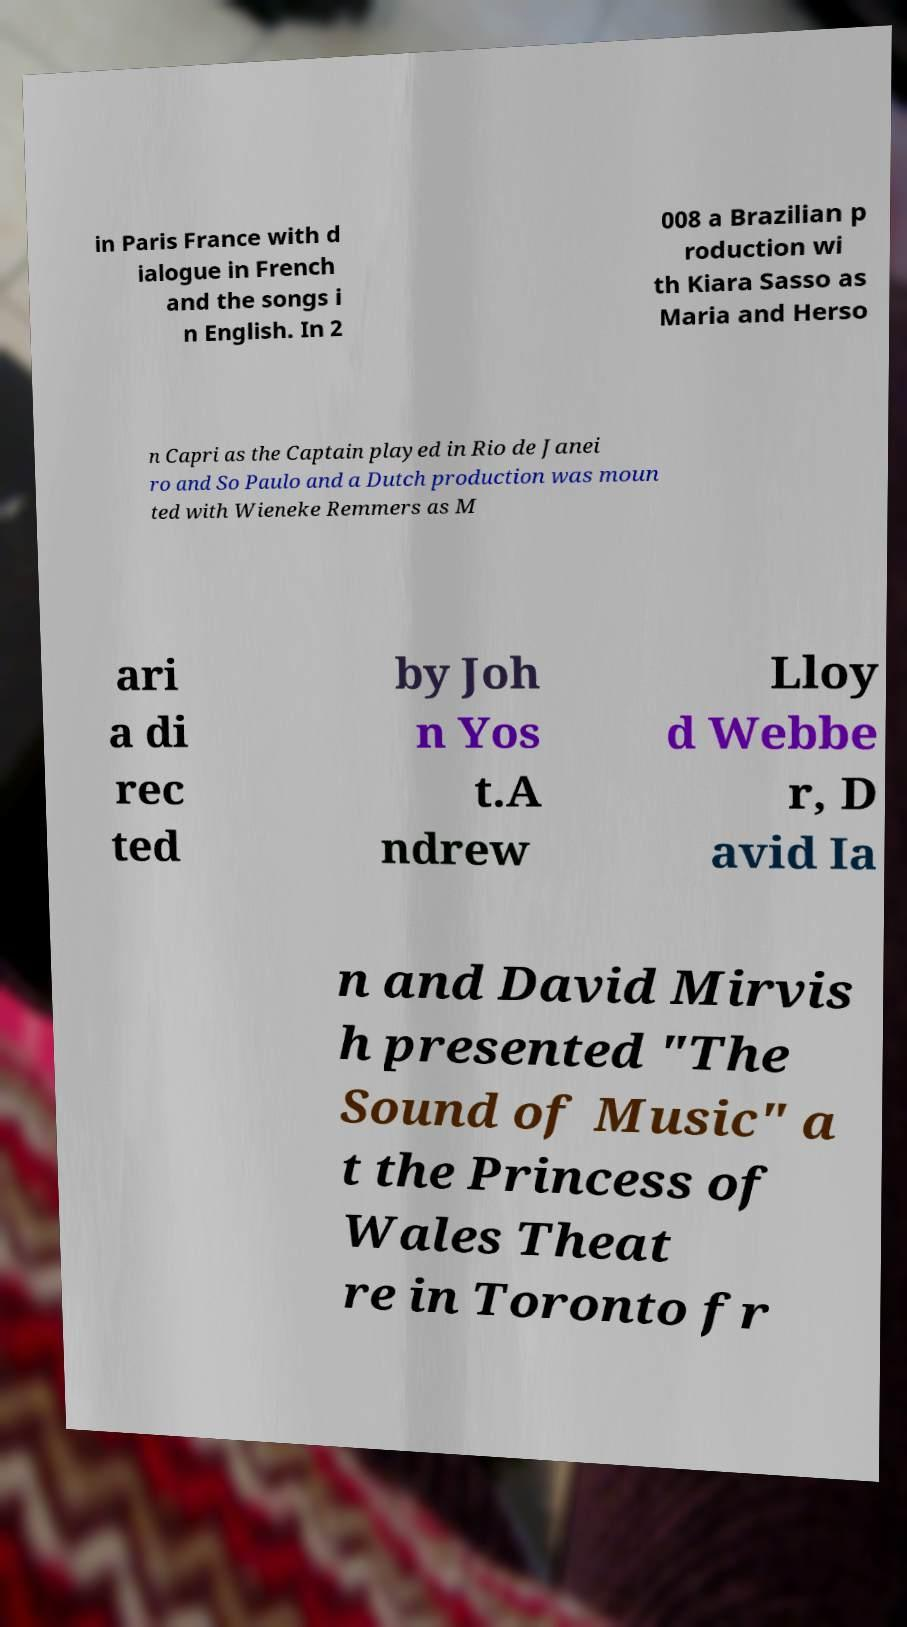Can you accurately transcribe the text from the provided image for me? in Paris France with d ialogue in French and the songs i n English. In 2 008 a Brazilian p roduction wi th Kiara Sasso as Maria and Herso n Capri as the Captain played in Rio de Janei ro and So Paulo and a Dutch production was moun ted with Wieneke Remmers as M ari a di rec ted by Joh n Yos t.A ndrew Lloy d Webbe r, D avid Ia n and David Mirvis h presented "The Sound of Music" a t the Princess of Wales Theat re in Toronto fr 